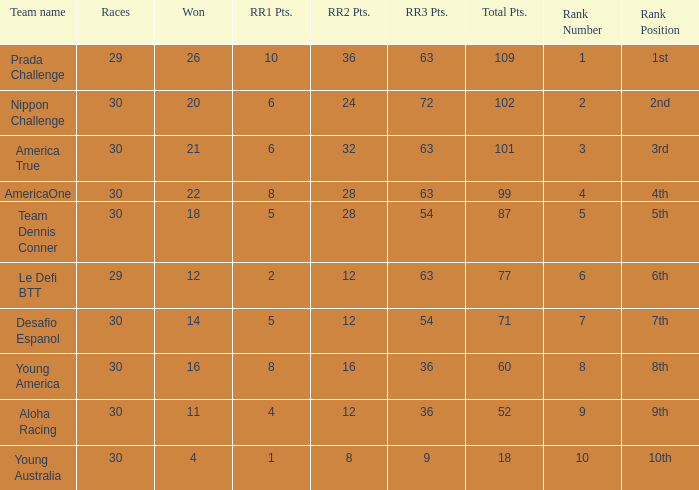Name the total number of rr2 pts for won being 11 1.0. 